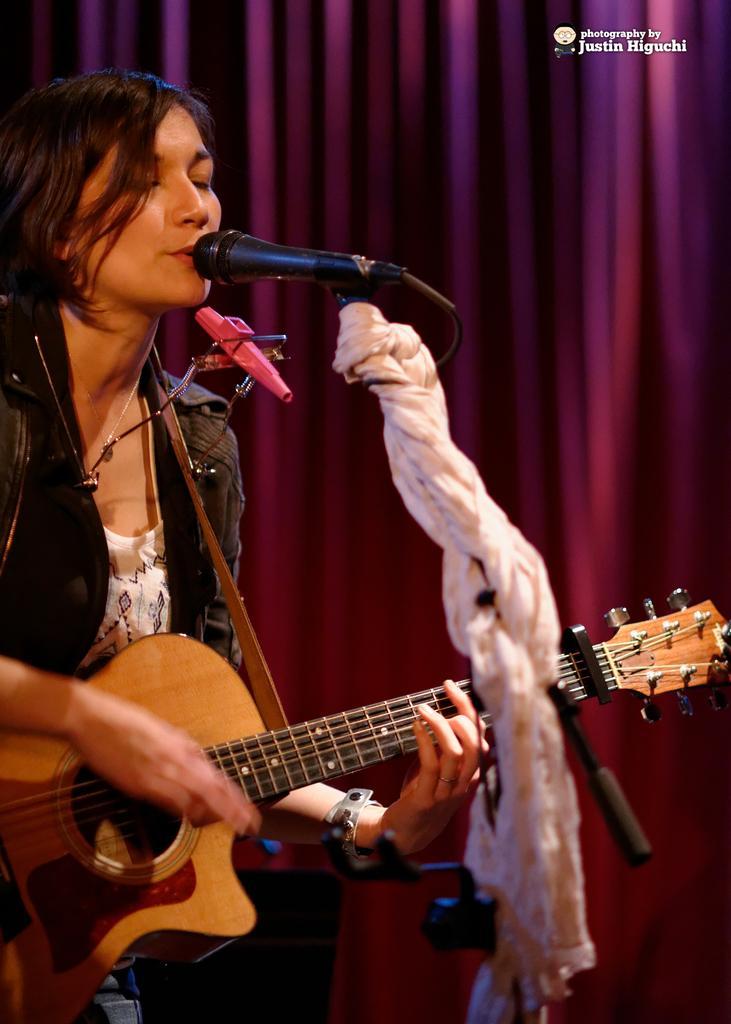In one or two sentences, can you explain what this image depicts? This woman wore jacket, playing guitar and singing in-front of mic. On this mic there is a scarf. Far there is a curtain in pinkish color. This guitar has strings and in brown color. 